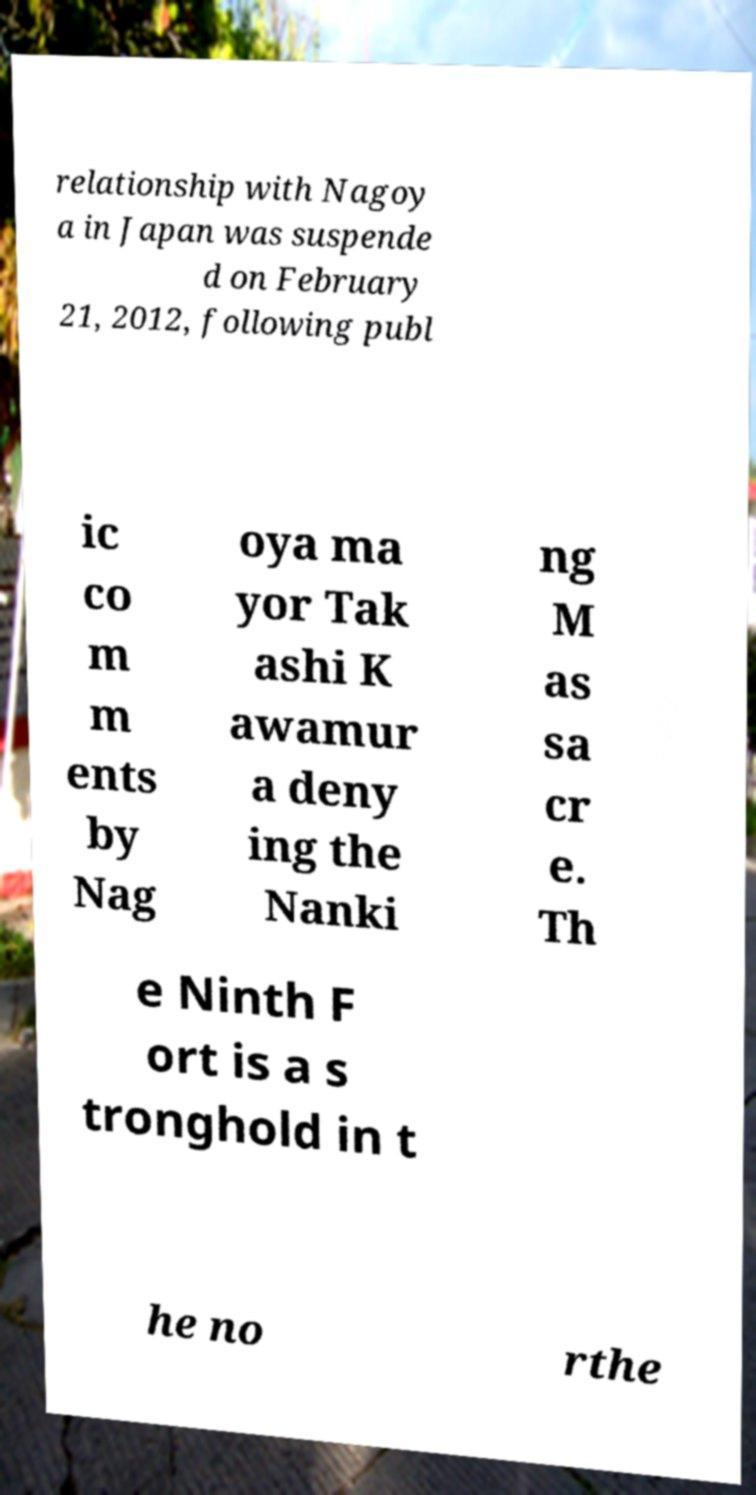Please identify and transcribe the text found in this image. relationship with Nagoy a in Japan was suspende d on February 21, 2012, following publ ic co m m ents by Nag oya ma yor Tak ashi K awamur a deny ing the Nanki ng M as sa cr e. Th e Ninth F ort is a s tronghold in t he no rthe 